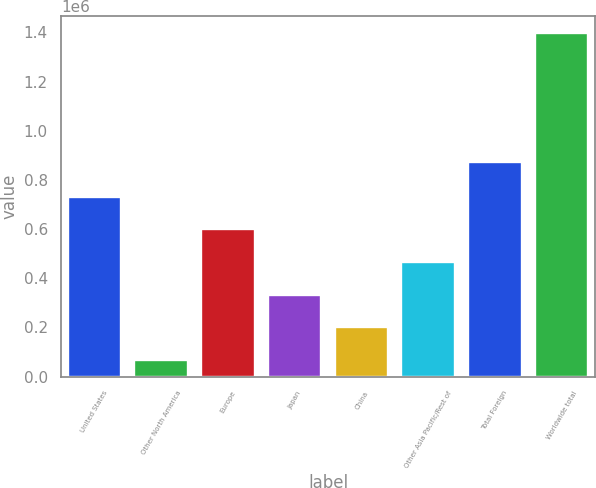Convert chart to OTSL. <chart><loc_0><loc_0><loc_500><loc_500><bar_chart><fcel>United States<fcel>Other North America<fcel>Europe<fcel>Japan<fcel>China<fcel>Other Asia Pacific/Rest of<fcel>Total Foreign<fcel>Worldwide total<nl><fcel>732518<fcel>67189<fcel>599452<fcel>333320<fcel>200255<fcel>466386<fcel>872534<fcel>1.39785e+06<nl></chart> 